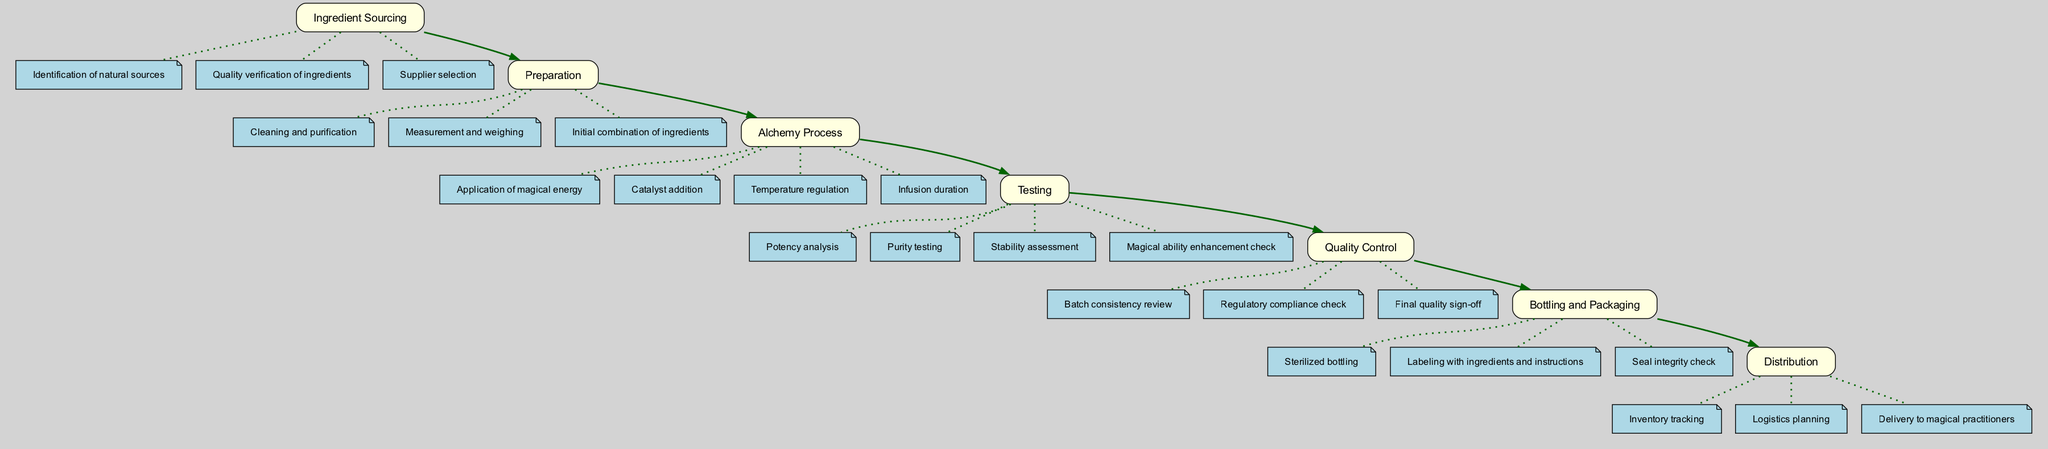What is the first stage in the elixir development cycle? The diagram indicates the first stage is "Ingredient Sourcing," placed at the top of the flow. This stage initiates the cycle by identifying sources for ingredients before any other steps are taken.
Answer: Ingredient Sourcing How many key elements are associated with the Alchemy Process stage? By examining the connections from the "Alchemy Process" stage, we find there are four key elements listed, showing the various activities that occur during this stage.
Answer: 4 What follows the Testing stage in the elixir development cycle? The diagram shows a direct arrow leading from the "Testing" stage to the "Quality Control" stage, indicating this sequential relationship in the development cycle.
Answer: Quality Control Which stage includes the element 'Labeling with ingredients and instructions'? The element 'Labeling with ingredients and instructions' is a key part of the "Bottling and Packaging" stage, as indicated by the direct association shown in the diagram.
Answer: Bottling and Packaging What is the last stage of the elixir development cycle? The final stage is depicted as "Distribution," which is outlined at the bottom of the diagram, completing the cycle of development from ingredients to delivery.
Answer: Distribution How many stages are there in total within the elixir development cycle? Counting all the distinct stages listed from "Ingredient Sourcing" to "Distribution" provides a total of seven stages, representing the entire cycle comprehensively.
Answer: 7 What key element is associated with the Preparation stage? The diagram features several elements linked to the "Preparation" stage, one of which is "Cleaning and purification," illustrating an essential aspect of preparing the elixir.
Answer: Cleaning and purification What is the primary purpose of the Quality Control stage? Quality Control serves to ensure that the elixirs meet standards for batch consistency, regulatory compliance, and provides a final quality sign-off before distribution, as indicated in the diagram.
Answer: Ensure quality 